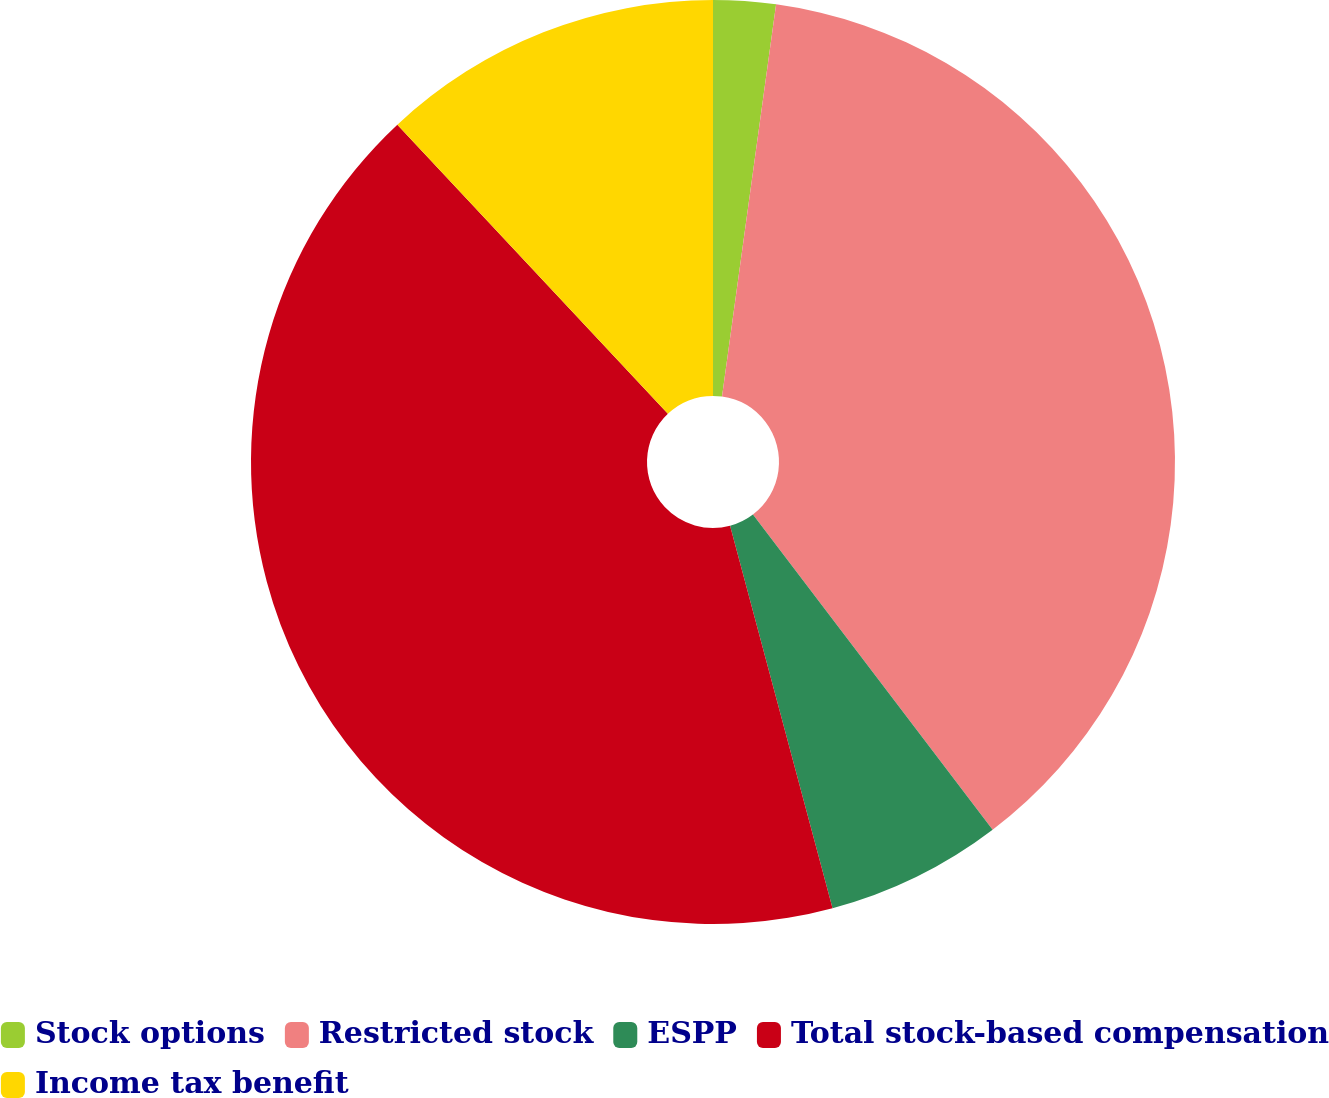Convert chart to OTSL. <chart><loc_0><loc_0><loc_500><loc_500><pie_chart><fcel>Stock options<fcel>Restricted stock<fcel>ESPP<fcel>Total stock-based compensation<fcel>Income tax benefit<nl><fcel>2.18%<fcel>37.47%<fcel>6.18%<fcel>42.19%<fcel>11.97%<nl></chart> 